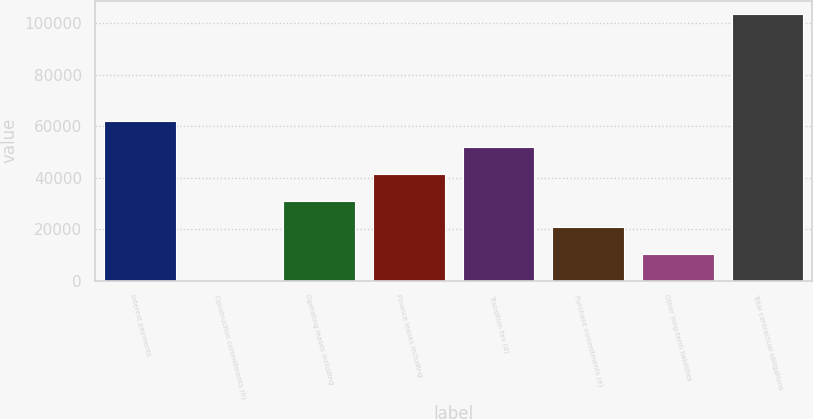Convert chart to OTSL. <chart><loc_0><loc_0><loc_500><loc_500><bar_chart><fcel>Interest payments<fcel>Construction commitments (b)<fcel>Operating leases including<fcel>Finance leases including<fcel>Transition tax (d)<fcel>Purchase commitments (e)<fcel>Other long-term liabilities<fcel>Total contractual obligations<nl><fcel>62102.1<fcel>3.73<fcel>31052.9<fcel>41402.7<fcel>51752.4<fcel>20703.2<fcel>10353.5<fcel>103501<nl></chart> 